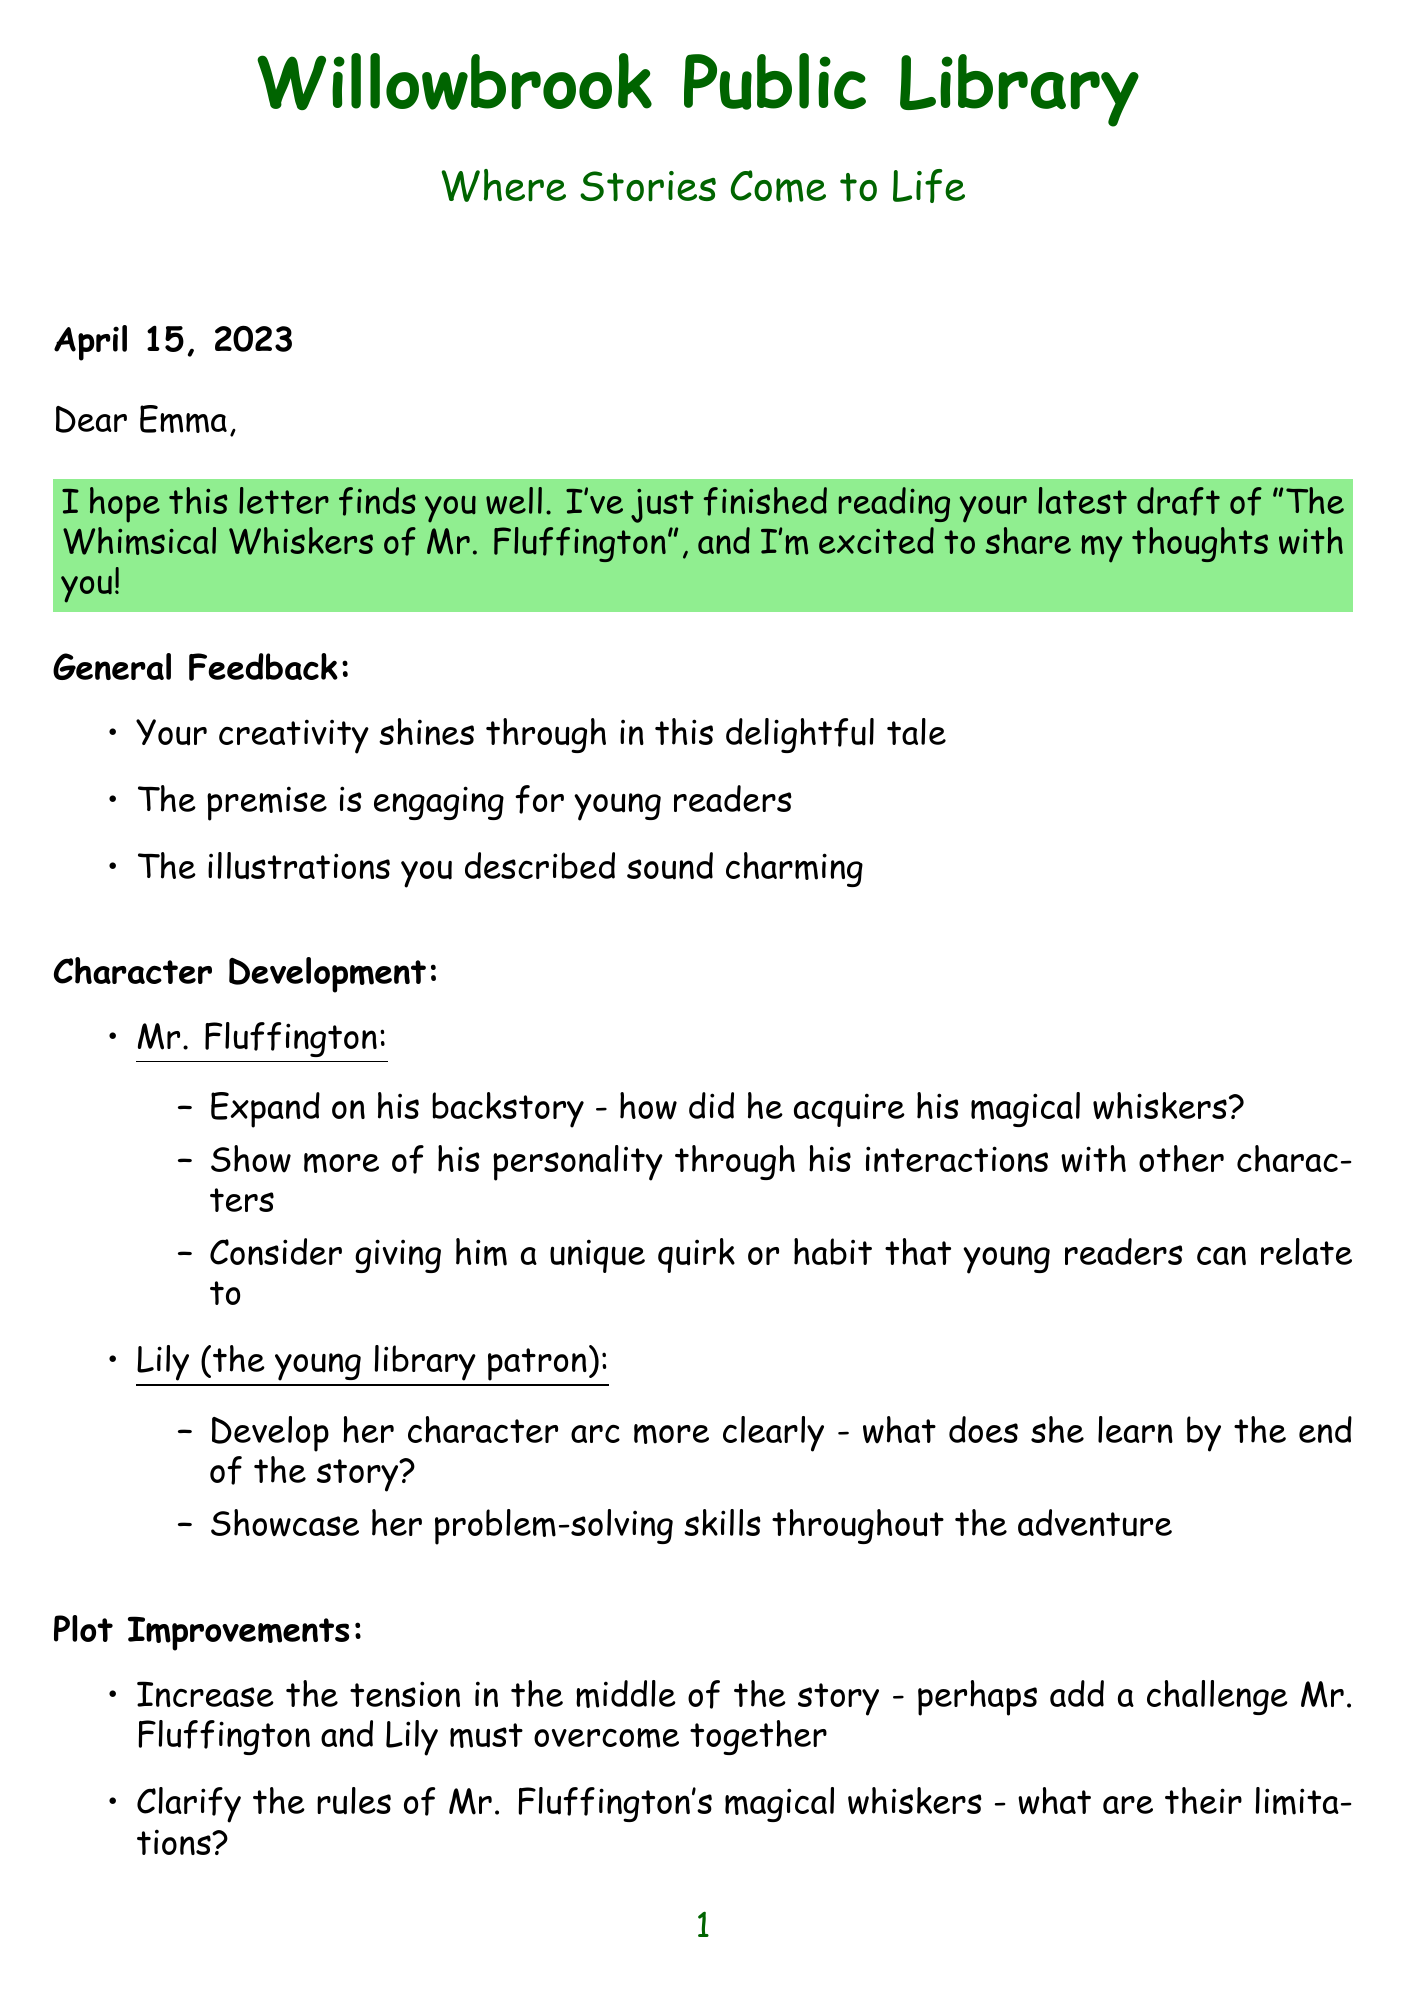What is the title of the story? The title is presented in the letter and states the main focus of the feedback provided.
Answer: The Whimsical Whiskers of Mr. Fluffington Who is the main character of the story? The letter specifies the character being discussed in the feedback.
Answer: Mr. Fluffington When was the letter written? The date at the top of the letter indicates when the feedback was provided.
Answer: April 15, 2023 What is the setting of the story? The setting is mentioned in the letter and is crucial to the narrative.
Answer: Enchanted Forest Library What is one of the character development suggestions for Lily? The letter lists suggestions for character development specific to Lily, indicating her role in the story.
Answer: Develop her character arc more clearly What could increase the story's tension according to the feedback? The letter suggests plot improvements that could enhance the story's engagement level for young readers.
Answer: Add a challenge Mr. Fluffington and Lily must overcome What theme is emphasized in the feedback for the story? The letter highlights important themes that the author should focus on within the story.
Answer: Friendship What is one suggestion regarding the pacing of the story? The letter provides specific feedback on pacing issues in the story's structure.
Answer: The beginning feels a bit rushed What potential does the letter suggest for the story? The marketability section of the letter indicates future prospects for the story.
Answer: Great potential for a series What is Olivia's title mentioned in the letter? The closing of the letter concludes with Olivia's professional identifier.
Answer: Head Librarian 